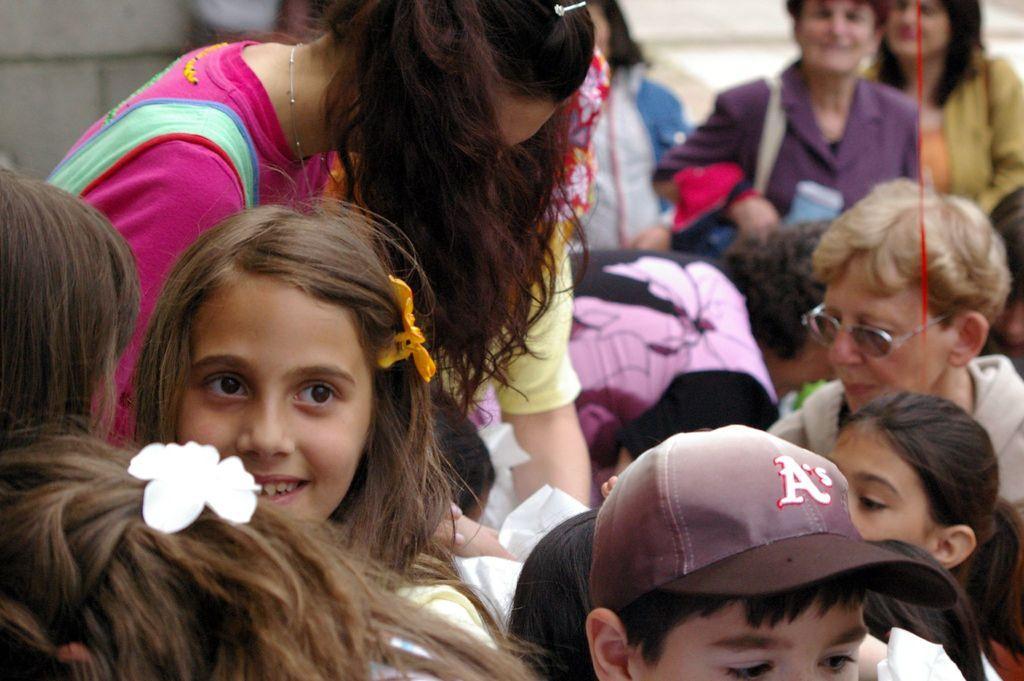Can you describe this image briefly? As we can see in the image there are group of people here and there and there is a wall. 